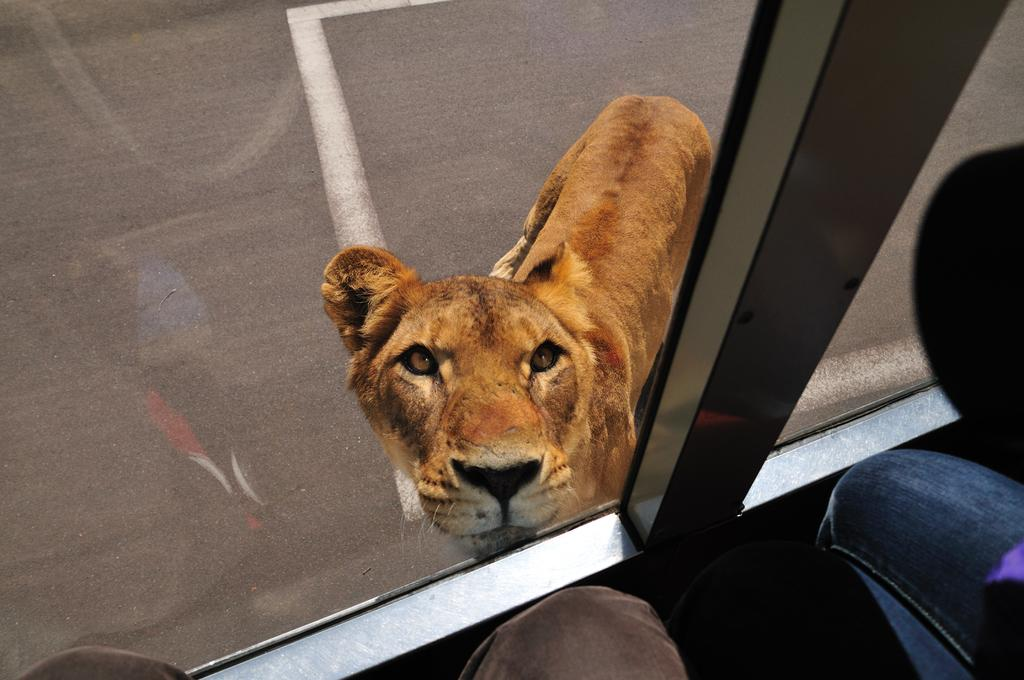What animal is present in the image? There is a lioness in the image. What might be the vantage point of the person taking the image? The image appears to be taken from a vehicle. What type of surface can be seen at the bottom of the image? There is a road visible at the bottom of the image. What type of bomb can be seen in the image? There is no bomb present in the image; it features a lioness and a road. How many things are visible in the image? It is difficult to quantify the number of "things" visible in the image, as it depends on how one defines "thing." However, we can definitively say that there is a lioness, a road, and a vehicle (implied by the vantage point). 